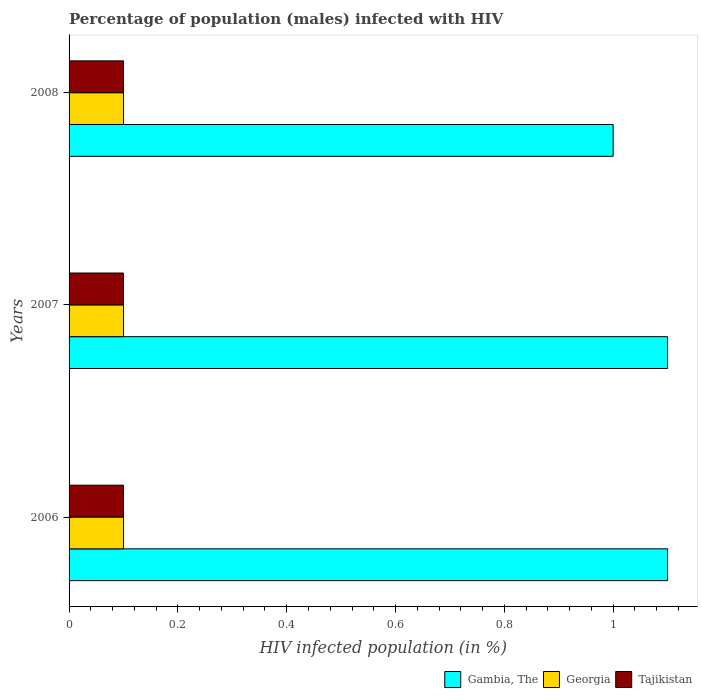Are the number of bars per tick equal to the number of legend labels?
Make the answer very short. Yes. Are the number of bars on each tick of the Y-axis equal?
Ensure brevity in your answer.  Yes. How many bars are there on the 3rd tick from the top?
Give a very brief answer. 3. How many bars are there on the 3rd tick from the bottom?
Give a very brief answer. 3. In how many cases, is the number of bars for a given year not equal to the number of legend labels?
Provide a succinct answer. 0. What is the percentage of HIV infected male population in Gambia, The in 2006?
Provide a succinct answer. 1.1. What is the difference between the percentage of HIV infected male population in Gambia, The in 2007 and that in 2008?
Your answer should be very brief. 0.1. What is the average percentage of HIV infected male population in Georgia per year?
Make the answer very short. 0.1. In the year 2006, what is the difference between the percentage of HIV infected male population in Gambia, The and percentage of HIV infected male population in Tajikistan?
Your answer should be compact. 1. In how many years, is the percentage of HIV infected male population in Georgia greater than 0.6000000000000001 %?
Your answer should be very brief. 0. Is the percentage of HIV infected male population in Gambia, The in 2006 less than that in 2008?
Your answer should be compact. No. In how many years, is the percentage of HIV infected male population in Georgia greater than the average percentage of HIV infected male population in Georgia taken over all years?
Offer a very short reply. 0. Is the sum of the percentage of HIV infected male population in Georgia in 2006 and 2007 greater than the maximum percentage of HIV infected male population in Tajikistan across all years?
Offer a terse response. Yes. What does the 3rd bar from the top in 2006 represents?
Your response must be concise. Gambia, The. What does the 1st bar from the bottom in 2006 represents?
Your answer should be very brief. Gambia, The. How many years are there in the graph?
Make the answer very short. 3. Are the values on the major ticks of X-axis written in scientific E-notation?
Offer a terse response. No. Does the graph contain grids?
Provide a succinct answer. No. Where does the legend appear in the graph?
Offer a terse response. Bottom right. How many legend labels are there?
Ensure brevity in your answer.  3. What is the title of the graph?
Provide a succinct answer. Percentage of population (males) infected with HIV. What is the label or title of the X-axis?
Your response must be concise. HIV infected population (in %). What is the HIV infected population (in %) in Tajikistan in 2006?
Provide a succinct answer. 0.1. What is the HIV infected population (in %) in Gambia, The in 2007?
Provide a short and direct response. 1.1. What is the HIV infected population (in %) in Gambia, The in 2008?
Ensure brevity in your answer.  1. What is the HIV infected population (in %) of Tajikistan in 2008?
Your answer should be compact. 0.1. Across all years, what is the maximum HIV infected population (in %) in Gambia, The?
Offer a very short reply. 1.1. Across all years, what is the maximum HIV infected population (in %) of Georgia?
Give a very brief answer. 0.1. Across all years, what is the minimum HIV infected population (in %) of Gambia, The?
Offer a very short reply. 1. Across all years, what is the minimum HIV infected population (in %) in Tajikistan?
Provide a short and direct response. 0.1. What is the total HIV infected population (in %) in Gambia, The in the graph?
Give a very brief answer. 3.2. What is the total HIV infected population (in %) of Tajikistan in the graph?
Your answer should be compact. 0.3. What is the difference between the HIV infected population (in %) in Georgia in 2006 and that in 2007?
Provide a short and direct response. 0. What is the difference between the HIV infected population (in %) of Tajikistan in 2006 and that in 2007?
Make the answer very short. 0. What is the difference between the HIV infected population (in %) of Gambia, The in 2006 and that in 2008?
Keep it short and to the point. 0.1. What is the difference between the HIV infected population (in %) in Gambia, The in 2007 and that in 2008?
Your answer should be compact. 0.1. What is the difference between the HIV infected population (in %) in Gambia, The in 2006 and the HIV infected population (in %) in Tajikistan in 2007?
Make the answer very short. 1. What is the difference between the HIV infected population (in %) in Georgia in 2006 and the HIV infected population (in %) in Tajikistan in 2008?
Offer a terse response. 0. What is the difference between the HIV infected population (in %) of Georgia in 2007 and the HIV infected population (in %) of Tajikistan in 2008?
Provide a short and direct response. 0. What is the average HIV infected population (in %) of Gambia, The per year?
Give a very brief answer. 1.07. What is the average HIV infected population (in %) in Tajikistan per year?
Offer a very short reply. 0.1. In the year 2007, what is the difference between the HIV infected population (in %) of Georgia and HIV infected population (in %) of Tajikistan?
Provide a succinct answer. 0. In the year 2008, what is the difference between the HIV infected population (in %) in Gambia, The and HIV infected population (in %) in Georgia?
Give a very brief answer. 0.9. What is the ratio of the HIV infected population (in %) of Georgia in 2006 to that in 2007?
Ensure brevity in your answer.  1. What is the ratio of the HIV infected population (in %) of Tajikistan in 2006 to that in 2007?
Keep it short and to the point. 1. What is the ratio of the HIV infected population (in %) of Georgia in 2006 to that in 2008?
Your answer should be compact. 1. What is the ratio of the HIV infected population (in %) of Georgia in 2007 to that in 2008?
Your response must be concise. 1. What is the ratio of the HIV infected population (in %) in Tajikistan in 2007 to that in 2008?
Keep it short and to the point. 1. What is the difference between the highest and the second highest HIV infected population (in %) of Gambia, The?
Offer a very short reply. 0. What is the difference between the highest and the second highest HIV infected population (in %) of Georgia?
Make the answer very short. 0. What is the difference between the highest and the second highest HIV infected population (in %) of Tajikistan?
Your answer should be very brief. 0. 